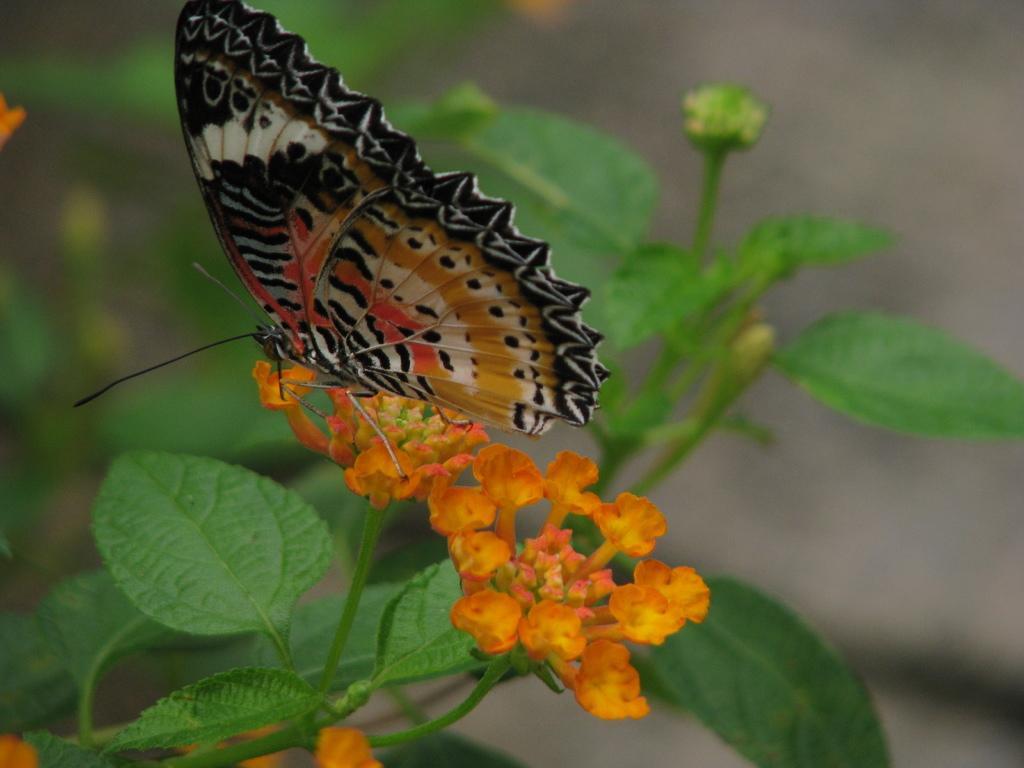In one or two sentences, can you explain what this image depicts? In the center of the image, we can see a butterfly on the flowers and in the background, we can see a plant. 